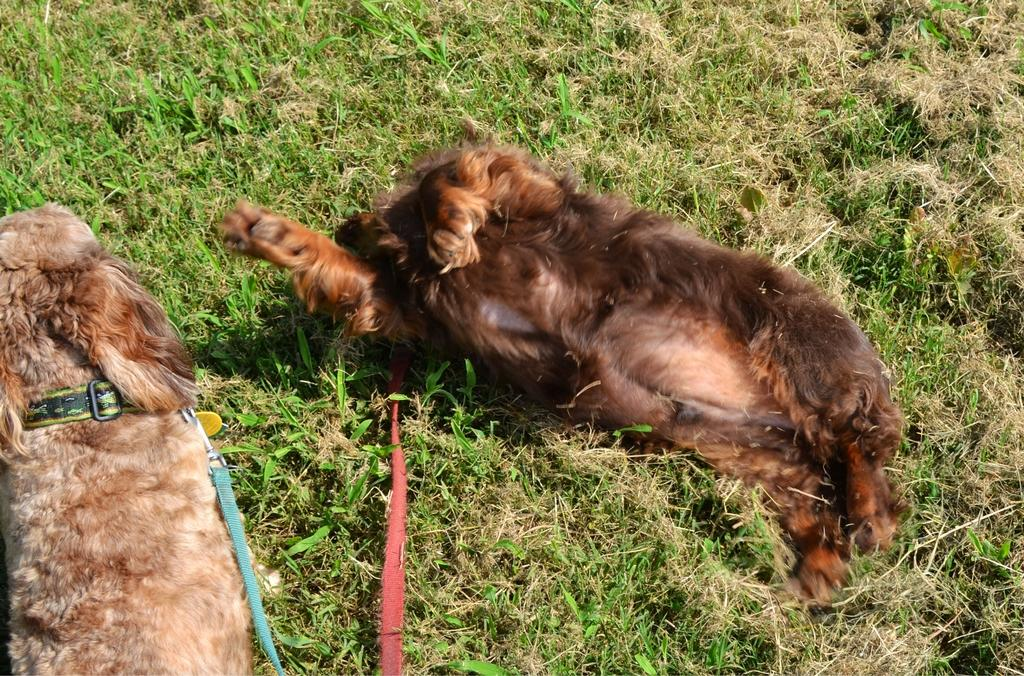What animals are present in the image? There are dogs in the image. What position are the dogs in? The dogs are lying on the ground. Are the dogs wearing any accessories in the image? Yes, the dogs have belts. What type of surface is the dogs lying on? The ground is covered with grass. What type of lunch is being served on the waves in the image? There are no waves or lunch present in the image; it features dogs lying on the ground with grass. 